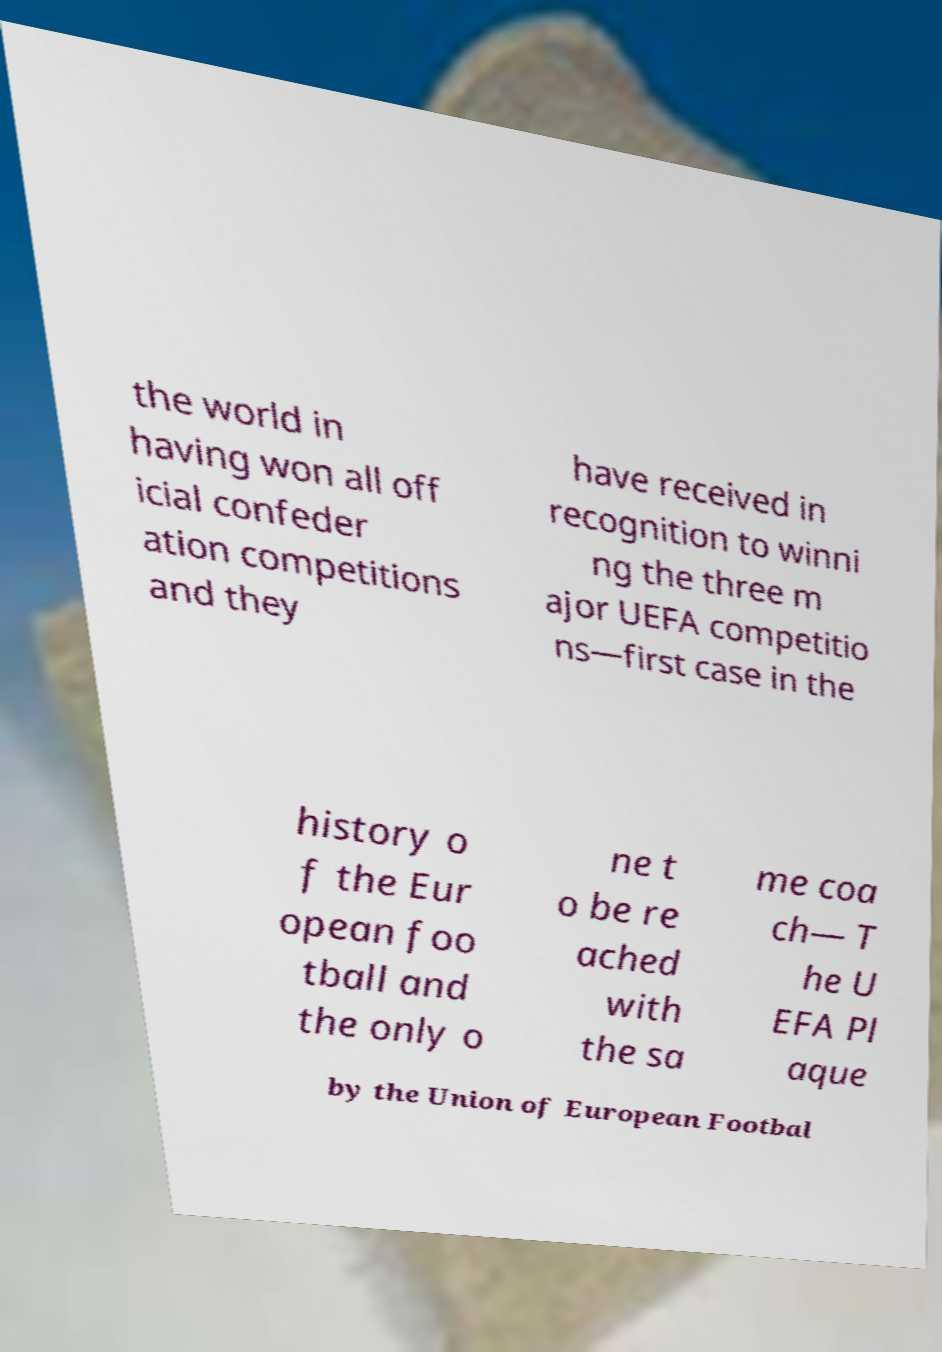Can you accurately transcribe the text from the provided image for me? the world in having won all off icial confeder ation competitions and they have received in recognition to winni ng the three m ajor UEFA competitio ns—first case in the history o f the Eur opean foo tball and the only o ne t o be re ached with the sa me coa ch— T he U EFA Pl aque by the Union of European Footbal 